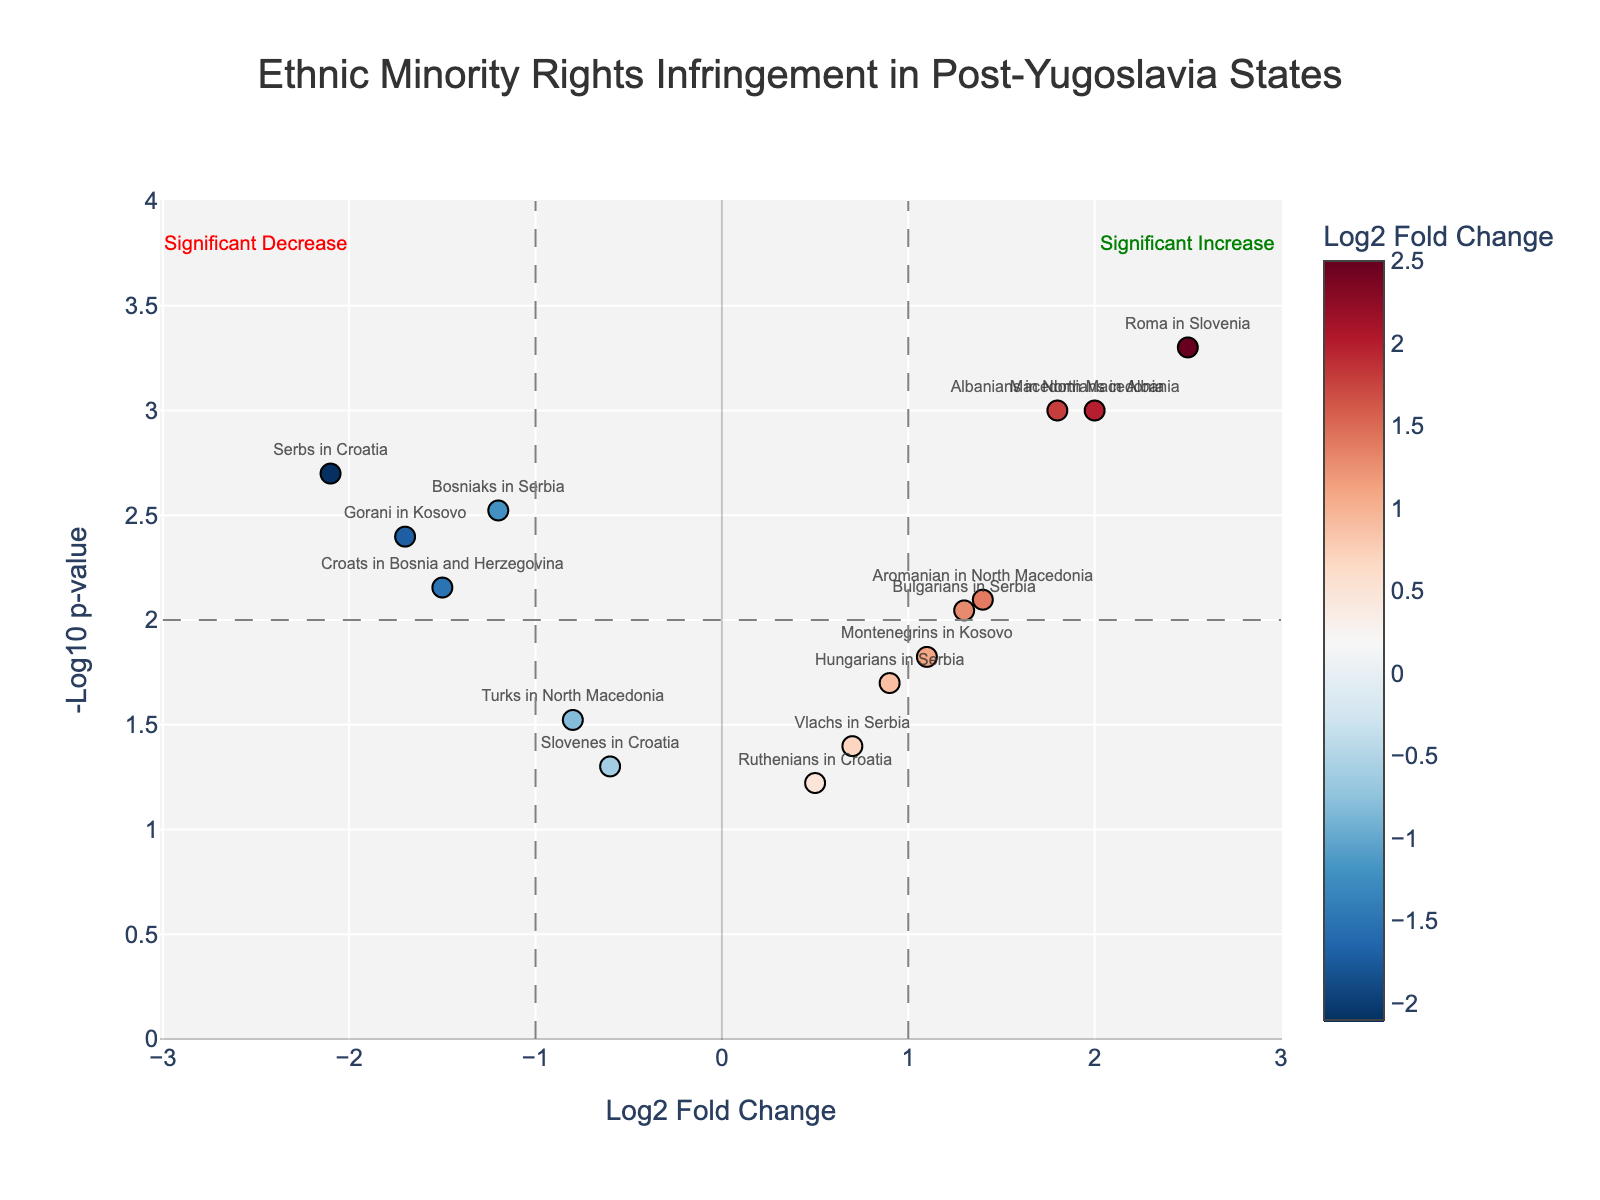what is the title of the plot? The title of the plot is located at the top center in a larger font. It reads 'Ethnic Minority Rights Infringement in Post-Yugoslavia States'.
Answer: Ethnic Minority Rights Infringement in Post-Yugoslavia States What is the range of Log2 Fold Change values? The Log2 Fold Change axis (x-axis) shows values from around -3 to 3, as observed by the axis ticks.
Answer: -3 to 3 Which ethnic group shows the highest infringement in terms of Log2 Fold Change? By looking at the category with the highest positive Log2 Fold Change, we can see that the Roma in Slovenia group has a Log2 Fold Change of 2.5.
Answer: Roma in Slovenia Which ethnic groups have p-values lower than 0.01? Ethnic groups with -log10(p-value) greater than 2 (since -log10(0.01) = 2) include Bosniaks in Serbia, Albanians in North Macedonia, Serbs in Croatia, Roma in Slovenia, Croats in Bosnia and Herzegovina, Montenegrins in Kosovo, Bulgarians in Serbia, Gorani in Kosovo, Macedonians in Albania, and Aromanian in North Macedonia.
Answer: Bosniaks in Serbia, Albanians in North Macedonia, Serbs in Croatia, Roma in Slovenia, Croats in Bosnia and Herzegovina, Montenegrins in Kosovo, Bulgarians in Serbia, Gorani in Kosovo, Macedonians in Albania, Aromanian in North Macedonia Which ethnic group shows the most significant decrease in terms of Log2 Fold Change? The most significant decrease in Log2 Fold Change is shown by the Serbs in Croatia with a value of -2.1.
Answer: Serbs in Croatia What does the dashed vertical line at -1 indicate? The vertical dashed line at -1 indicates a threshold value separating significant decreases in Log2 Fold Change.
Answer: Threshold for significant decrease How many ethnic groups are displaying significant increases but have a Log2 Fold Change less than 2? By examining the groups with a -log10(p-value) greater than 2 and Log2 Fold Change less than 2, we see there are four: Albanians in North Macedonia, Montenegrins in Kosovo, Bulgarians in Serbia, and Aromanian in North Macedonia.
Answer: Four Which ethnic group has the lowest p-value among those with a significant increasing Log2 Fold Change? Among those with significant increases (higher Log2 Fold Change and low p-value), the Roma in Slovenia have the lowest p-value, as inferred from the highest -log10(p-value) and the highest Log2 Fold Change.
Answer: Roma in Slovenia Are there more ethnic groups with significant increases or significant decreases in rights infringement? Comparing the number of ethnic groups with -log10(p-value) greater than 2 and positive Log2 Fold Change (significant increases) against those with negative Log2 Fold Change (significant decreases), we have 5 with significant increases and 5 with significant decreases.
Answer: Equal What does the horizontal dashed line at 2 signify? The horizontal dashed line at 2 represents the threshold for statistical significance in p-values, as -log10(0.01) equals 2.
Answer: Threshold for statistical significance 